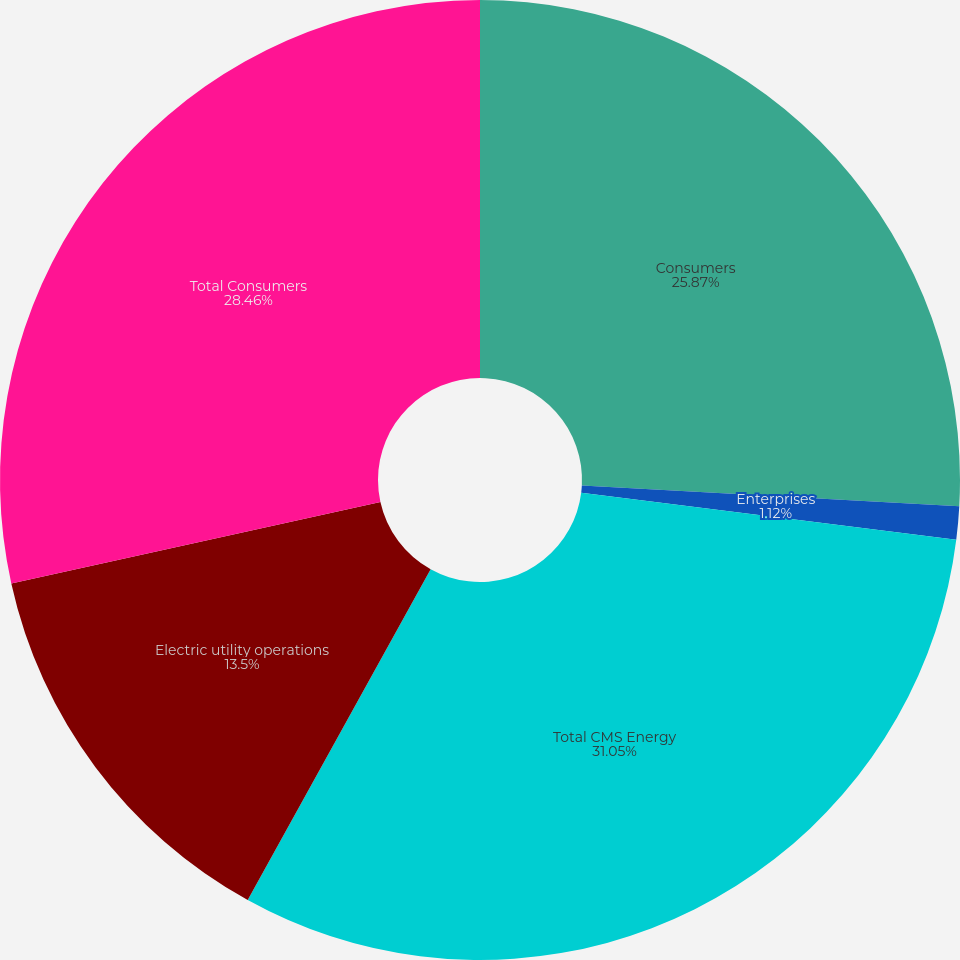Convert chart to OTSL. <chart><loc_0><loc_0><loc_500><loc_500><pie_chart><fcel>Consumers<fcel>Enterprises<fcel>Total CMS Energy<fcel>Electric utility operations<fcel>Total Consumers<nl><fcel>25.87%<fcel>1.12%<fcel>31.05%<fcel>13.5%<fcel>28.46%<nl></chart> 